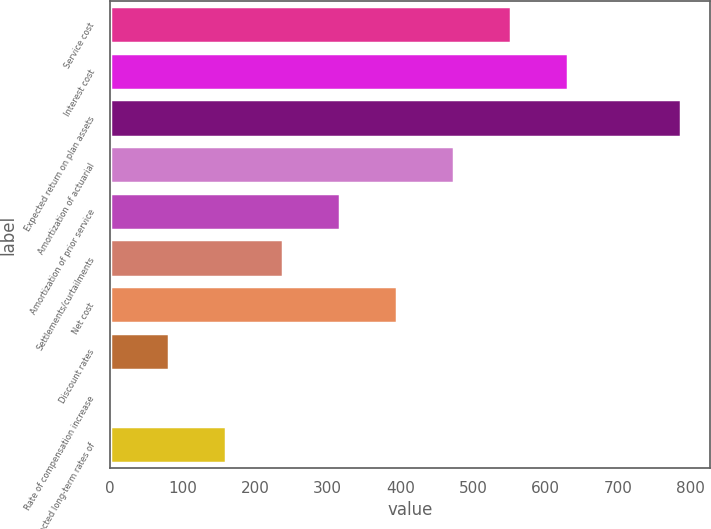Convert chart. <chart><loc_0><loc_0><loc_500><loc_500><bar_chart><fcel>Service cost<fcel>Interest cost<fcel>Expected return on plan assets<fcel>Amortization of actuarial<fcel>Amortization of prior service<fcel>Settlements/curtailments<fcel>Net cost<fcel>Discount rates<fcel>Rate of compensation increase<fcel>Expected long-term rates of<nl><fcel>552.07<fcel>630.38<fcel>787<fcel>473.76<fcel>317.14<fcel>238.83<fcel>395.45<fcel>82.21<fcel>3.9<fcel>160.52<nl></chart> 